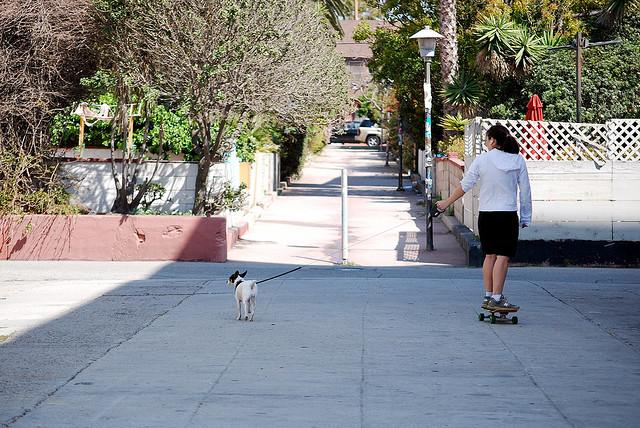Is the umbrella open?
Give a very brief answer. No. What kind of animal is in the photo?
Quick response, please. Dog. Is the dog running?
Short answer required. No. What is this person standing on?
Answer briefly. Skateboard. 